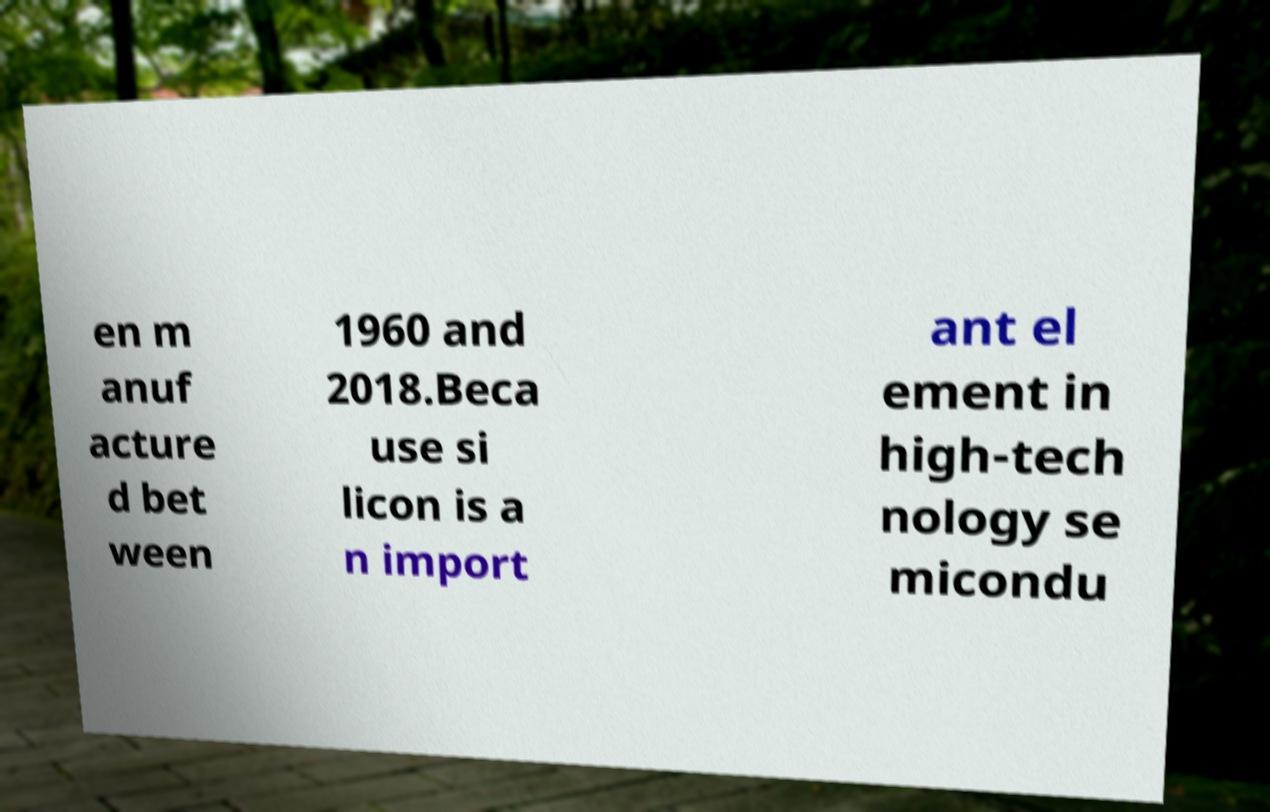Please read and relay the text visible in this image. What does it say? en m anuf acture d bet ween 1960 and 2018.Beca use si licon is a n import ant el ement in high-tech nology se micondu 